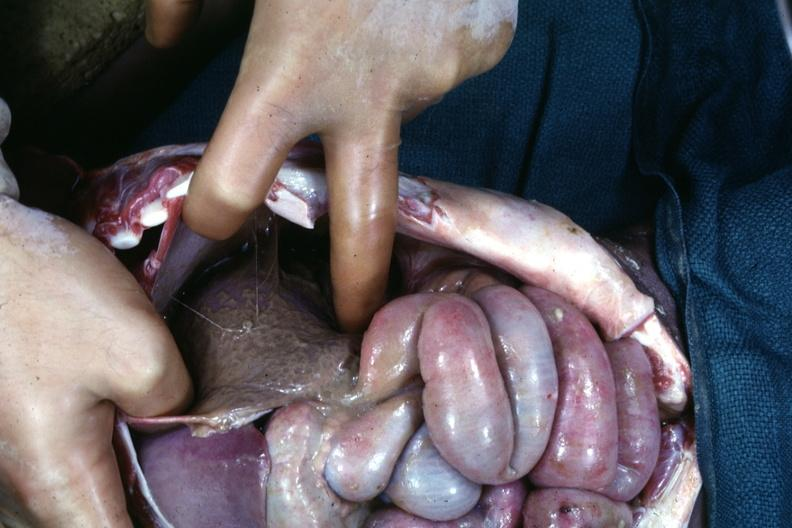does tuberculosis show an opened peritoneal cavity cause by fibrous band strangulation see other slides?
Answer the question using a single word or phrase. No 